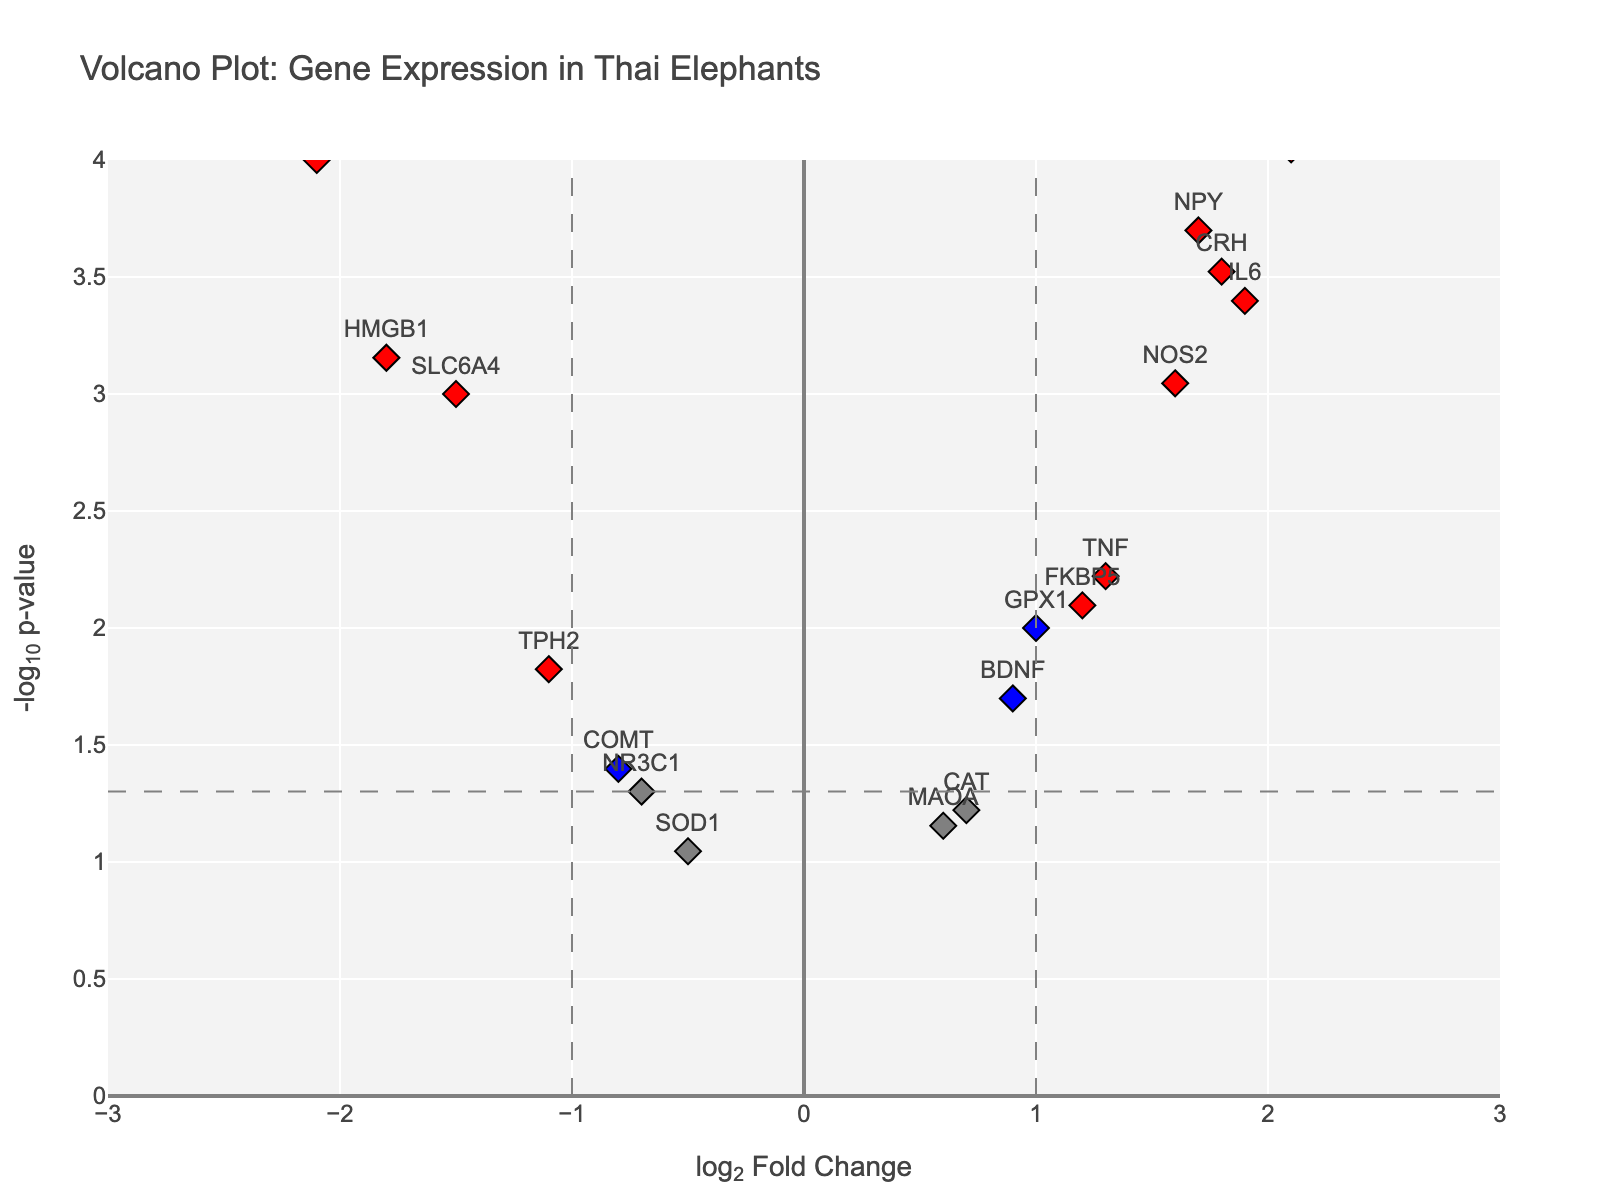Which gene has the highest -log10(p-value) and what is its log2FoldChange? To identify the gene with the highest -log10(p-value), look at the point plotted at the highest position on the y-axis and check its corresponding gene label and log2FoldChange on the x-axis.
Answer: CRHR1, 2.5 How many genes show significant changes with a log2FoldChange greater than 1 in both directions? To find significant genes, look for those with high -log10(p-value) values (above the horizontal threshold line). Then, count those with log2FoldChange greater than 1 and less than -1 (past the vertical lines).
Answer: 4 (CRH, OXTR, CRHR1, HSP70) Which gene has the largest negative log2FoldChange and is statistically significant? Look for the gene with the lowest negative log2FoldChange value where the point is colored red, indicating significance.
Answer: POMC Are there more genes with upregulated or downregulated expression that are statistically significant? Identify the red points (significant changes) on both the positive (upregulated) and negative (downregulated) sides of the x-axis. Count the points.
Answer: Upregulated genes are more How many genes have a log2FoldChange between -1 and 1 but are still statistically significant? Look for genes within the range of -1 to 1 on the x-axis and with a high -log10(p-value) (above the horizontal threshold line). These points will be colored blue.
Answer: 5 (BDNF, FKBP5, TPH2, GPX1, NOS2) What is the log2FoldChange value for the gene IL6, and is it statistically significant? Find the specific point labeled IL6 and check its log2FoldChange value on the x-axis. The significance can be determined by its red color.
Answer: 1.9, Yes Which two genes have the closest -log10(p-value) values but different log2FoldChange values? Identify pairs of points that have similar heights on the y-axis but are spread apart on the x-axis. Compare their values.
Answer: BDNF and TPH2 What is the general trend of significant genes: are they mostly upregulated or downregulated? Examine the distribution of red points on both sides of the plot.
Answer: Mostly upregulated Which gene with a log2FoldChange below -1 has the smallest -log10(pvalue)? Find the gene with a log2FoldChange below -1 and the lowest position above the threshold on the y-axis.
Answer: SLC6A4 